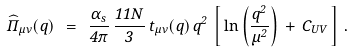<formula> <loc_0><loc_0><loc_500><loc_500>\widehat { \Pi } _ { \mu \nu } ( q ) \ = \ \frac { \alpha _ { s } } { 4 \pi } \, \frac { 1 1 N } { 3 } \, t _ { \mu \nu } ( q ) \, q ^ { 2 } \, \left [ \, \ln \left ( \frac { q ^ { 2 } } { \mu ^ { 2 } } \right ) \, + \, C _ { U V } \, \right ] \, .</formula> 